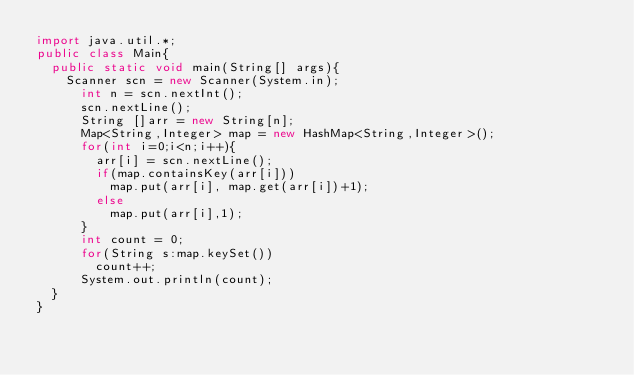<code> <loc_0><loc_0><loc_500><loc_500><_Java_>import java.util.*;
public class Main{
  public static void main(String[] args){
  	Scanner scn = new Scanner(System.in);
	    int n = scn.nextInt();
	    scn.nextLine();
	    String []arr = new String[n];
	    Map<String,Integer> map = new HashMap<String,Integer>();
	    for(int i=0;i<n;i++){
	      arr[i] = scn.nextLine();
	      if(map.containsKey(arr[i]))
	    	  map.put(arr[i], map.get(arr[i])+1);
	      else
	    	  map.put(arr[i],1);
	    }
	    int count = 0;
	    for(String s:map.keySet())
	    	count++;
	    System.out.println(count);
  }
}
</code> 